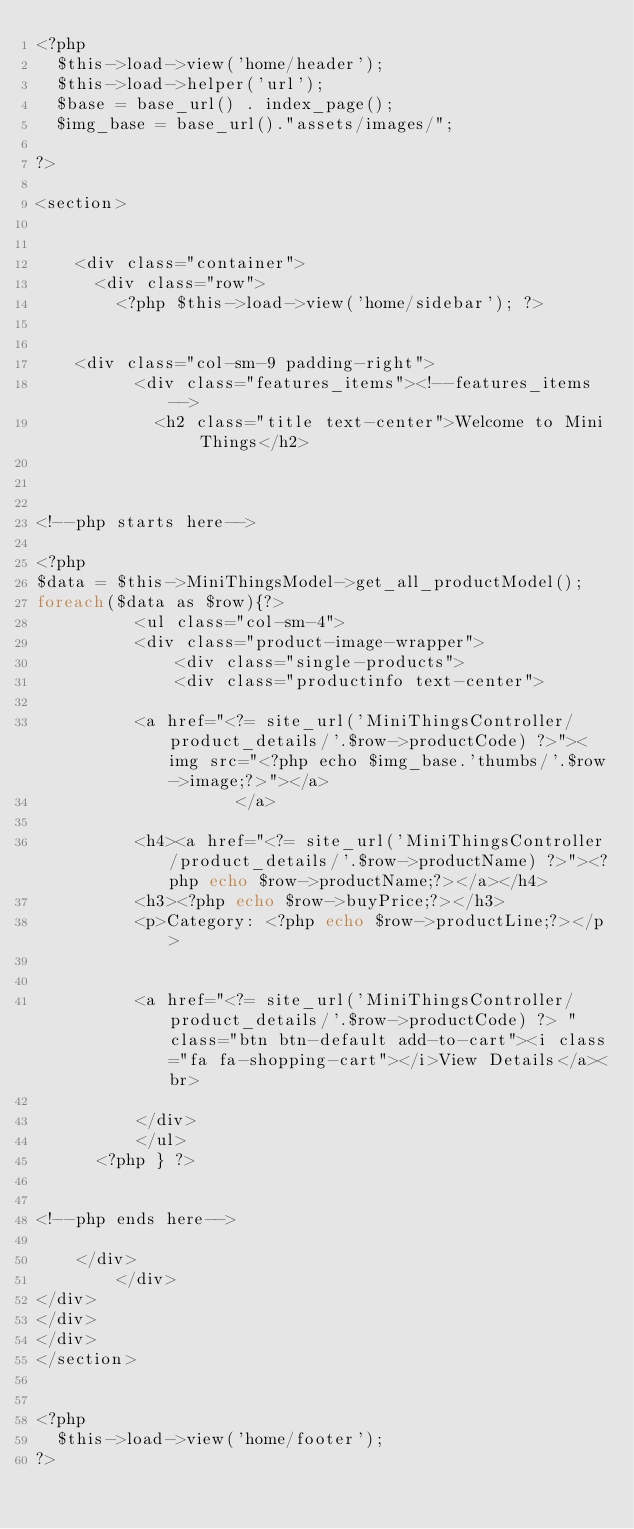<code> <loc_0><loc_0><loc_500><loc_500><_PHP_><?php
	$this->load->view('home/header'); 
	$this->load->helper('url');
	$base = base_url() . index_page();
	$img_base = base_url()."assets/images/";
	
?>

<section>


		<div class="container">
			<div class="row">
				<?php $this->load->view('home/sidebar'); ?>

                    
    <div class="col-sm-9 padding-right">
					<div class="features_items"><!--features_items-->
						<h2 class="title text-center">Welcome to Mini Things</h2>
						

							
<!--php starts here-->

<?php	
$data = $this->MiniThingsModel->get_all_productModel();
foreach($data as $row){?>			
					<ul class="col-sm-4">
					<div class="product-image-wrapper">
						  <div class="single-products">
						  <div class="productinfo text-center">
					
					<a href="<?= site_url('MiniThingsController/product_details/'.$row->productCode) ?>"><img src="<?php echo $img_base.'thumbs/'.$row->image;?>"></a>
                    </a>
					
					<h4><a href="<?= site_url('MiniThingsController/product_details/'.$row->productName) ?>"><?php echo $row->productName;?></a></h4>
					<h3><?php echo $row->buyPrice;?></h3>
					<p>Category: <?php echo $row->productLine;?></p>
					
					
					<a href="<?= site_url('MiniThingsController/product_details/'.$row->productCode) ?> " class="btn btn-default add-to-cart"><i class="fa fa-shopping-cart"></i>View Details</a><br>

					</div>		
					</ul>			
			<?php }	?>


<!--php ends here-->
		
		</div>
        </div>
</div>
</div>
</div>
</section>

	
<?php
	$this->load->view('home/footer'); 
?></code> 